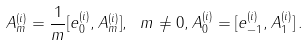<formula> <loc_0><loc_0><loc_500><loc_500>A _ { m } ^ { ( i ) } = \frac { 1 } { m } [ e _ { 0 } ^ { ( i ) } , A _ { m } ^ { ( i ) } ] , \ m \ne 0 , A _ { 0 } ^ { ( i ) } = [ e _ { - 1 } ^ { ( i ) } , A _ { 1 } ^ { ( i ) } ] \, .</formula> 